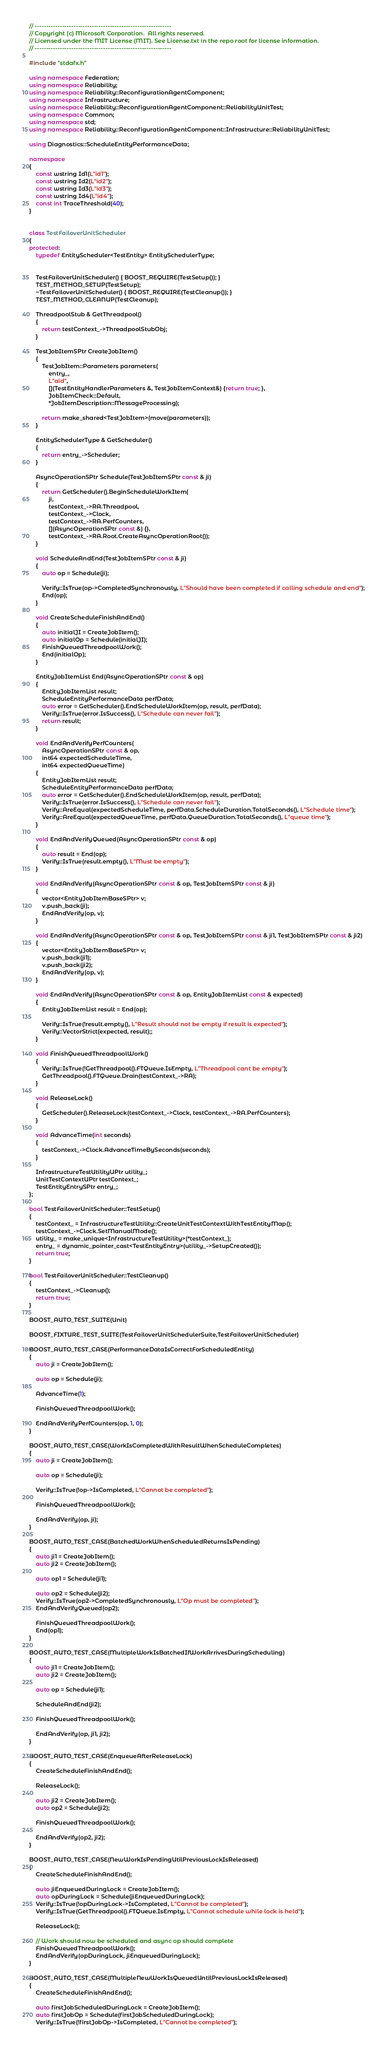Convert code to text. <code><loc_0><loc_0><loc_500><loc_500><_C++_>// ------------------------------------------------------------
// Copyright (c) Microsoft Corporation.  All rights reserved.
// Licensed under the MIT License (MIT). See License.txt in the repo root for license information.
// ------------------------------------------------------------

#include "stdafx.h"

using namespace Federation;
using namespace Reliability;
using namespace Reliability::ReconfigurationAgentComponent;
using namespace Infrastructure;
using namespace Reliability::ReconfigurationAgentComponent::ReliabilityUnitTest;
using namespace Common;
using namespace std;
using namespace Reliability::ReconfigurationAgentComponent::Infrastructure::ReliabilityUnitTest;

using Diagnostics::ScheduleEntityPerformanceData;

namespace
{
    const wstring Id1(L"id1");
    const wstring Id2(L"id2");
    const wstring Id3(L"id3");
    const wstring Id4(L"id4");
    const int TraceThreshold(40);
}


class TestFailoverUnitScheduler
{
protected:
    typedef EntityScheduler<TestEntity> EntitySchedulerType;
    

    TestFailoverUnitScheduler() { BOOST_REQUIRE(TestSetup()); }
    TEST_METHOD_SETUP(TestSetup);
    ~TestFailoverUnitScheduler() { BOOST_REQUIRE(TestCleanup()); }
    TEST_METHOD_CLEANUP(TestCleanup);

    ThreadpoolStub & GetThreadpool()
    {
        return testContext_->ThreadpoolStubObj;
    }

    TestJobItemSPtr CreateJobItem()
    {
        TestJobItem::Parameters parameters(
            entry_,
            L"aid",
            [](TestEntityHandlerParameters &, TestJobItemContext&) {return true; },
            JobItemCheck::Default,
            *JobItemDescription::MessageProcessing);

        return make_shared<TestJobItem>(move(parameters));
    }

    EntitySchedulerType & GetScheduler()
    {
        return entry_->Scheduler;
    }

    AsyncOperationSPtr Schedule(TestJobItemSPtr const & ji)
    {
        return GetScheduler().BeginScheduleWorkItem(
            ji,
            testContext_->RA.Threadpool,
            testContext_->Clock,
            testContext_->RA.PerfCounters,
            [](AsyncOperationSPtr const &) {},
            testContext_->RA.Root.CreateAsyncOperationRoot());
    }

    void ScheduleAndEnd(TestJobItemSPtr const & ji)
    {
        auto op = Schedule(ji);

        Verify::IsTrue(op->CompletedSynchronously, L"Should have been completed if calling schedule and end");
        End(op);
    }

    void CreateScheduleFinishAndEnd()
    {
        auto initialJI = CreateJobItem();
        auto initialOp = Schedule(initialJI);
        FinishQueuedThreadpoolWork();
        End(initialOp);
    }

    EntityJobItemList End(AsyncOperationSPtr const & op)
    {
        EntityJobItemList result;
        ScheduleEntityPerformanceData perfData;
        auto error = GetScheduler().EndScheduleWorkItem(op, result, perfData);
        Verify::IsTrue(error.IsSuccess(), L"Schedule can never fail");
        return result;
    }

    void EndAndVerifyPerfCounters(
        AsyncOperationSPtr const & op, 
        int64 expectedScheduleTime,
        int64 expectedQueueTime)
    {
        EntityJobItemList result;
        ScheduleEntityPerformanceData perfData;
        auto error = GetScheduler().EndScheduleWorkItem(op, result, perfData);
        Verify::IsTrue(error.IsSuccess(), L"Schedule can never fail");        
        Verify::AreEqual(expectedScheduleTime, perfData.ScheduleDuration.TotalSeconds(), L"Schedule time");
        Verify::AreEqual(expectedQueueTime, perfData.QueueDuration.TotalSeconds(), L"queue time");
    }

    void EndAndVerifyQueued(AsyncOperationSPtr const & op)
    {
        auto result = End(op);
        Verify::IsTrue(result.empty(), L"Must be empty");
    }

    void EndAndVerify(AsyncOperationSPtr const & op, TestJobItemSPtr const & ji)
    {
        vector<EntityJobItemBaseSPtr> v;
        v.push_back(ji);
        EndAndVerify(op, v);
    }

    void EndAndVerify(AsyncOperationSPtr const & op, TestJobItemSPtr const & ji1, TestJobItemSPtr const & ji2)
    {
        vector<EntityJobItemBaseSPtr> v;
        v.push_back(ji1);
        v.push_back(ji2);
        EndAndVerify(op, v);
    }

    void EndAndVerify(AsyncOperationSPtr const & op, EntityJobItemList const & expected)
    {
        EntityJobItemList result = End(op);
        
        Verify::IsTrue(!result.empty(), L"Result should not be empty if result is expected");
        Verify::VectorStrict(expected, result);;
    }

    void FinishQueuedThreadpoolWork()
    {
        Verify::IsTrue(!GetThreadpool().FTQueue.IsEmpty, L"Threadpool cant be empty");
        GetThreadpool().FTQueue.Drain(testContext_->RA);
    }

    void ReleaseLock()
    {
        GetScheduler().ReleaseLock(testContext_->Clock, testContext_->RA.PerfCounters);
    }

    void AdvanceTime(int seconds)
    {
        testContext_->Clock.AdvanceTimeBySeconds(seconds);
    }

    InfrastructureTestUtilityUPtr utility_;
    UnitTestContextUPtr testContext_;
    TestEntityEntrySPtr entry_;
};

bool TestFailoverUnitScheduler::TestSetup()
{
    testContext_ = InfrastructureTestUtility::CreateUnitTestContextWithTestEntityMap();
    testContext_->Clock.SetManualMode();
    utility_ = make_unique<InfrastructureTestUtility>(*testContext_); 
    entry_ = dynamic_pointer_cast<TestEntityEntry>(utility_->SetupCreated());
	return true;
}

bool TestFailoverUnitScheduler::TestCleanup()
{
	testContext_->Cleanup();
	return true;
}

BOOST_AUTO_TEST_SUITE(Unit)

BOOST_FIXTURE_TEST_SUITE(TestFailoverUnitSchedulerSuite,TestFailoverUnitScheduler)

BOOST_AUTO_TEST_CASE(PerformanceDataIsCorrectForScheduledEntity)
{
    auto ji = CreateJobItem();

    auto op = Schedule(ji);

    AdvanceTime(1);

    FinishQueuedThreadpoolWork();

    EndAndVerifyPerfCounters(op, 1, 0);
}

BOOST_AUTO_TEST_CASE(WorkIsCompletedWithResultWhenScheduleCompletes)
{
    auto ji = CreateJobItem();

    auto op = Schedule(ji);

    Verify::IsTrue(!op->IsCompleted, L"Cannot be completed");

    FinishQueuedThreadpoolWork();

    EndAndVerify(op, ji);
}

BOOST_AUTO_TEST_CASE(BatchedWorkWhenScheduledReturnsIsPending)
{
    auto ji1 = CreateJobItem();
    auto ji2 = CreateJobItem();

    auto op1 = Schedule(ji1);

    auto op2 = Schedule(ji2);
    Verify::IsTrue(op2->CompletedSynchronously, L"Op must be completed");
    EndAndVerifyQueued(op2);

    FinishQueuedThreadpoolWork();
    End(op1);
}

BOOST_AUTO_TEST_CASE(MultipleWorkIsBatchedIfWorkArrivesDuringScheduling)
{
    auto ji1 = CreateJobItem();
    auto ji2 = CreateJobItem();

    auto op = Schedule(ji1);
    
    ScheduleAndEnd(ji2);

    FinishQueuedThreadpoolWork();

    EndAndVerify(op, ji1, ji2);
}

BOOST_AUTO_TEST_CASE(EnqueueAfterReleaseLock)
{
    CreateScheduleFinishAndEnd();

    ReleaseLock();

    auto ji2 = CreateJobItem();
    auto op2 = Schedule(ji2);

    FinishQueuedThreadpoolWork();

    EndAndVerify(op2, ji2);
}

BOOST_AUTO_TEST_CASE(NewWorkIsPendingUtilPreviousLockIsReleased)
{
    CreateScheduleFinishAndEnd();

    auto jiEnqueuedDuringLock = CreateJobItem();
    auto opDuringLock = Schedule(jiEnqueuedDuringLock);
    Verify::IsTrue(!opDuringLock->IsCompleted, L"Cannot be completed");
    Verify::IsTrue(GetThreadpool().FTQueue.IsEmpty, L"Cannot schedule while lock is held");

    ReleaseLock();

    // Work should now be scheduled and async op should complete
    FinishQueuedThreadpoolWork();
    EndAndVerify(opDuringLock, jiEnqueuedDuringLock);
}

BOOST_AUTO_TEST_CASE(MultipleNewWorkIsQueuedUntilPreviousLockIsReleased)
{
    CreateScheduleFinishAndEnd();

    auto firstJobScheduledDuringLock = CreateJobItem();
    auto firstJobOp = Schedule(firstJobScheduledDuringLock);
    Verify::IsTrue(!firstJobOp->IsCompleted, L"Cannot be completed");</code> 